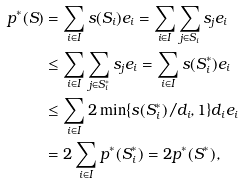<formula> <loc_0><loc_0><loc_500><loc_500>p ^ { * } ( S ) & = \sum _ { i \in I } s ( S _ { i } ) e _ { i } = \sum _ { i \in I } \sum _ { j \in S _ { i } } s _ { j } e _ { i } \\ & \leq \sum _ { i \in I } \sum _ { j \in S ^ { * } _ { i } } s _ { j } e _ { i } = \sum _ { i \in I } s ( S ^ { * } _ { i } ) e _ { i } \\ & \leq \sum _ { i \in I } 2 \min \{ s ( S ^ { * } _ { i } ) / d _ { i } , 1 \} d _ { i } e _ { i } \\ & = 2 \sum _ { i \in I } p ^ { * } ( S _ { i } ^ { * } ) = 2 p ^ { * } ( S ^ { * } ) ,</formula> 